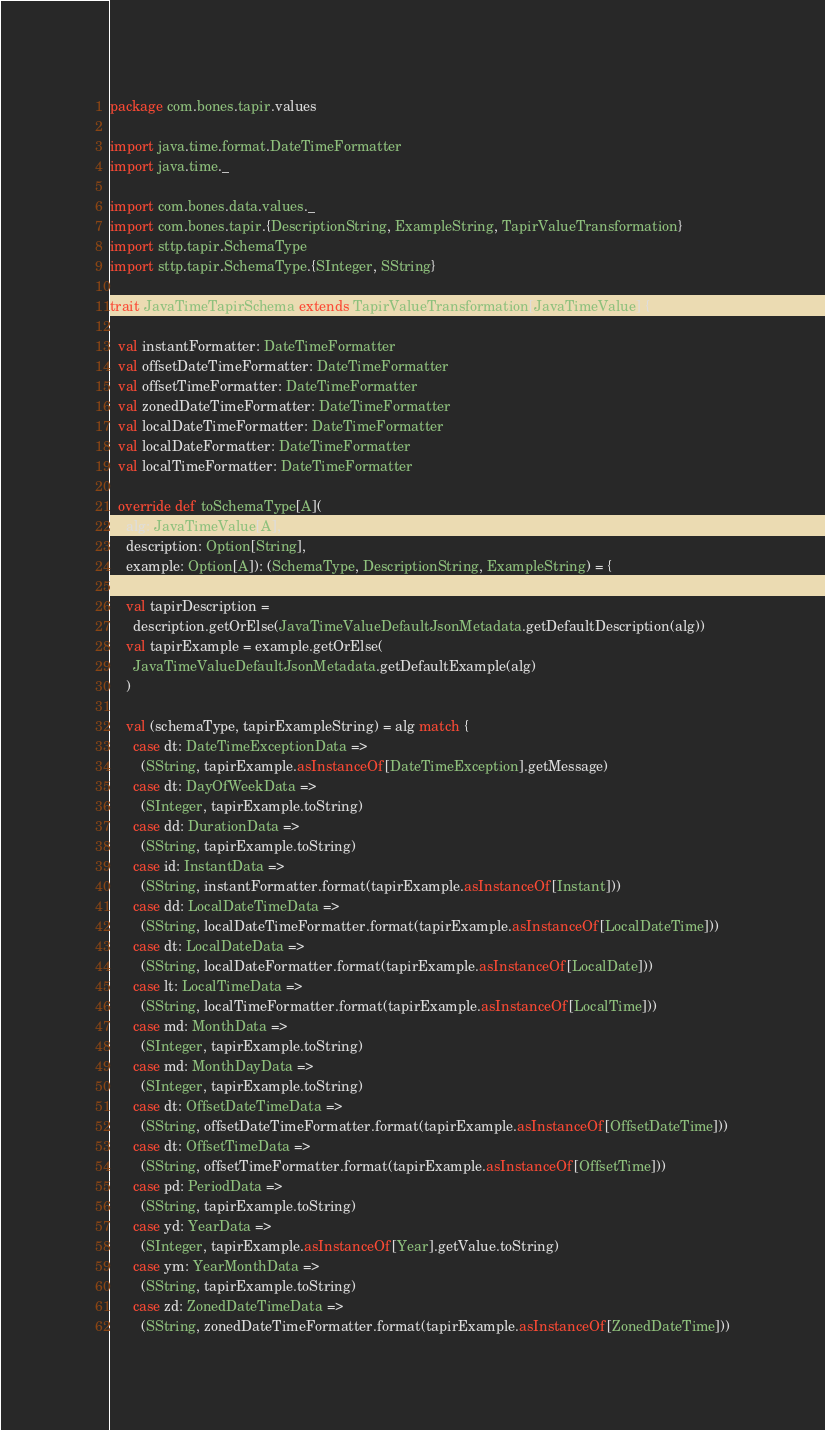<code> <loc_0><loc_0><loc_500><loc_500><_Scala_>package com.bones.tapir.values

import java.time.format.DateTimeFormatter
import java.time._

import com.bones.data.values._
import com.bones.tapir.{DescriptionString, ExampleString, TapirValueTransformation}
import sttp.tapir.SchemaType
import sttp.tapir.SchemaType.{SInteger, SString}

trait JavaTimeTapirSchema extends TapirValueTransformation[JavaTimeValue] {

  val instantFormatter: DateTimeFormatter
  val offsetDateTimeFormatter: DateTimeFormatter
  val offsetTimeFormatter: DateTimeFormatter
  val zonedDateTimeFormatter: DateTimeFormatter
  val localDateTimeFormatter: DateTimeFormatter
  val localDateFormatter: DateTimeFormatter
  val localTimeFormatter: DateTimeFormatter

  override def toSchemaType[A](
    alg: JavaTimeValue[A],
    description: Option[String],
    example: Option[A]): (SchemaType, DescriptionString, ExampleString) = {

    val tapirDescription =
      description.getOrElse(JavaTimeValueDefaultJsonMetadata.getDefaultDescription(alg))
    val tapirExample = example.getOrElse(
      JavaTimeValueDefaultJsonMetadata.getDefaultExample(alg)
    )

    val (schemaType, tapirExampleString) = alg match {
      case dt: DateTimeExceptionData =>
        (SString, tapirExample.asInstanceOf[DateTimeException].getMessage)
      case dt: DayOfWeekData =>
        (SInteger, tapirExample.toString)
      case dd: DurationData =>
        (SString, tapirExample.toString)
      case id: InstantData =>
        (SString, instantFormatter.format(tapirExample.asInstanceOf[Instant]))
      case dd: LocalDateTimeData =>
        (SString, localDateTimeFormatter.format(tapirExample.asInstanceOf[LocalDateTime]))
      case dt: LocalDateData =>
        (SString, localDateFormatter.format(tapirExample.asInstanceOf[LocalDate]))
      case lt: LocalTimeData =>
        (SString, localTimeFormatter.format(tapirExample.asInstanceOf[LocalTime]))
      case md: MonthData =>
        (SInteger, tapirExample.toString)
      case md: MonthDayData =>
        (SInteger, tapirExample.toString)
      case dt: OffsetDateTimeData =>
        (SString, offsetDateTimeFormatter.format(tapirExample.asInstanceOf[OffsetDateTime]))
      case dt: OffsetTimeData =>
        (SString, offsetTimeFormatter.format(tapirExample.asInstanceOf[OffsetTime]))
      case pd: PeriodData =>
        (SString, tapirExample.toString)
      case yd: YearData =>
        (SInteger, tapirExample.asInstanceOf[Year].getValue.toString)
      case ym: YearMonthData =>
        (SString, tapirExample.toString)
      case zd: ZonedDateTimeData =>
        (SString, zonedDateTimeFormatter.format(tapirExample.asInstanceOf[ZonedDateTime]))</code> 